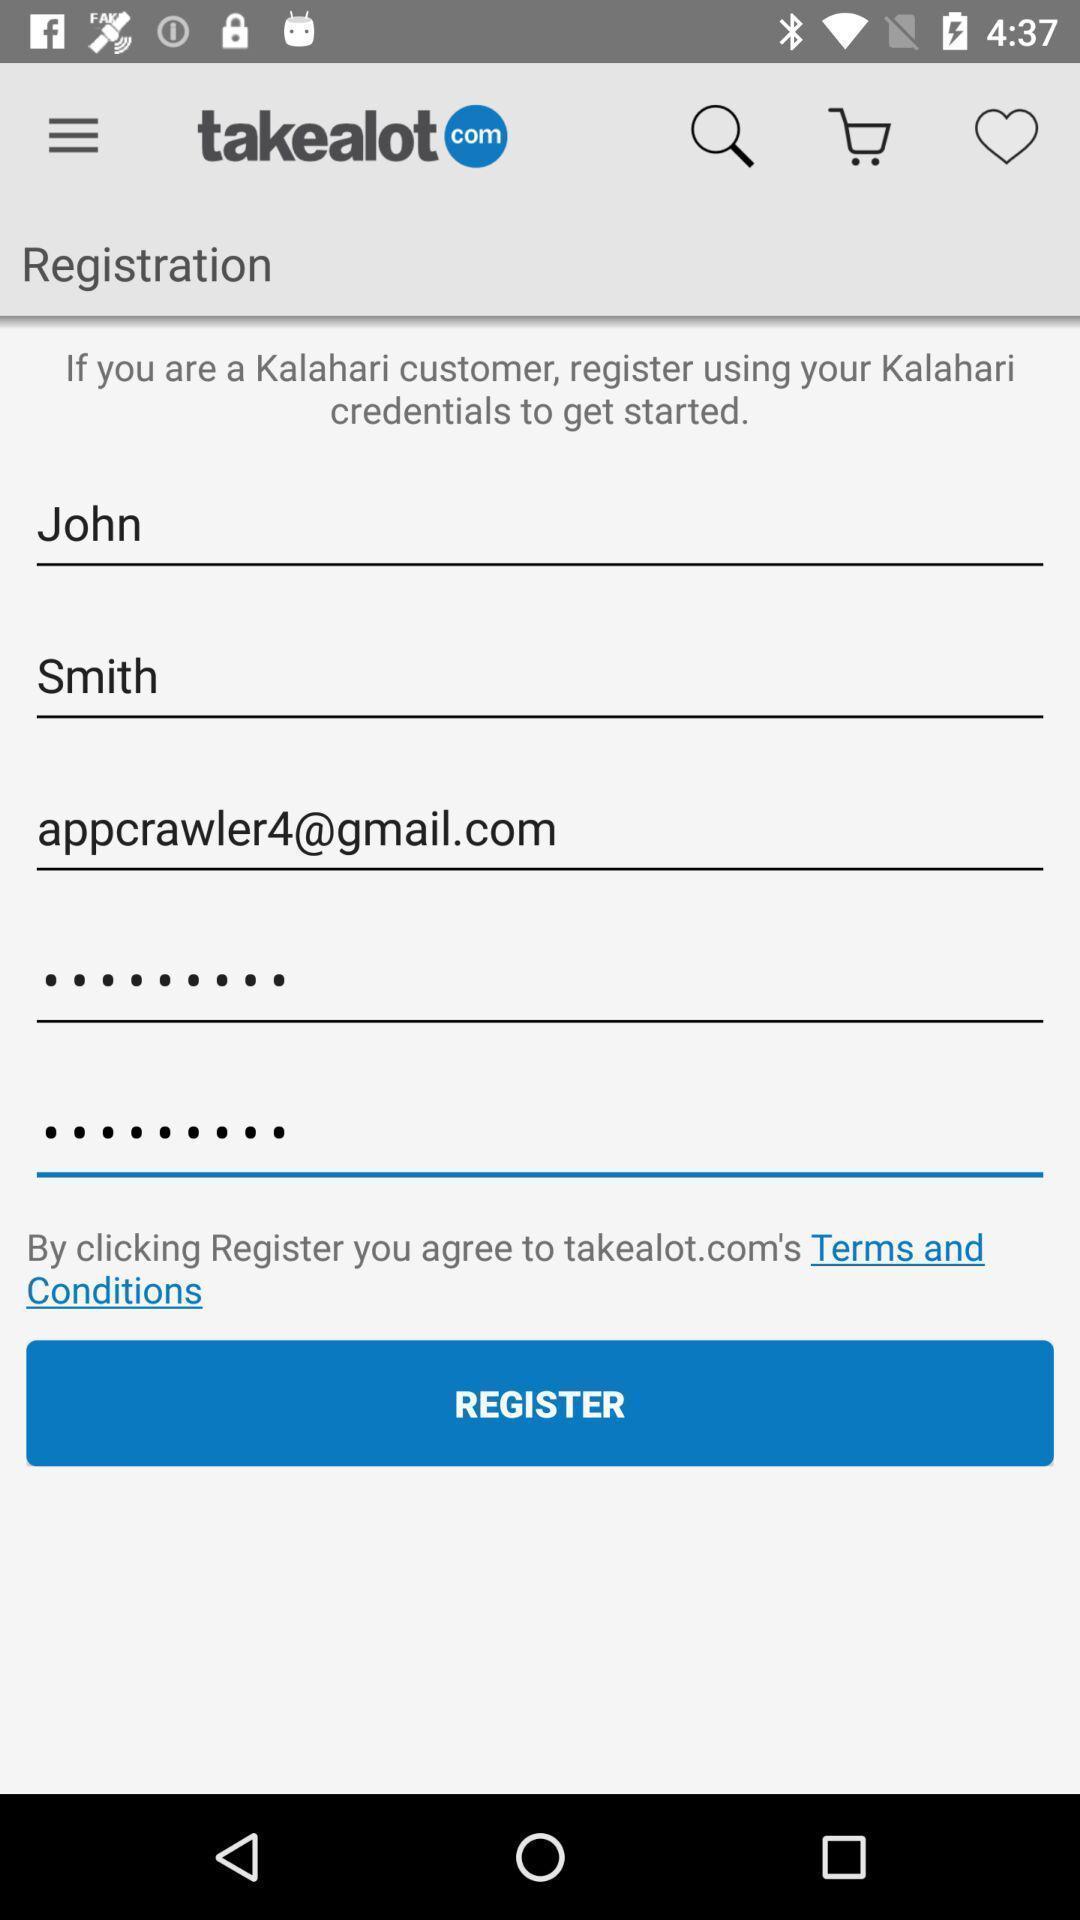What details can you identify in this image? Sign up page. 